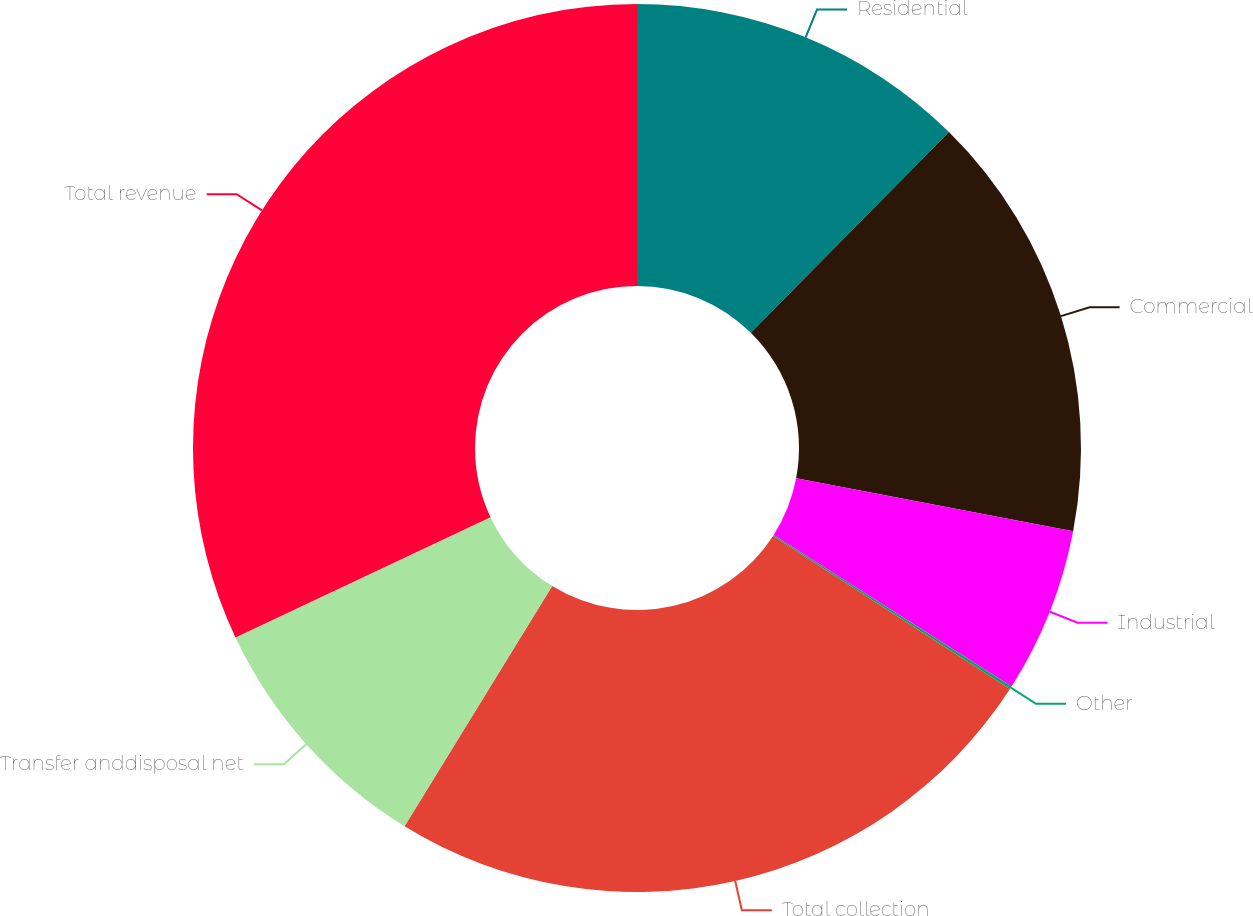Convert chart. <chart><loc_0><loc_0><loc_500><loc_500><pie_chart><fcel>Residential<fcel>Commercial<fcel>Industrial<fcel>Other<fcel>Total collection<fcel>Transfer anddisposal net<fcel>Total revenue<nl><fcel>12.4%<fcel>15.6%<fcel>6.02%<fcel>0.11%<fcel>24.64%<fcel>9.21%<fcel>32.02%<nl></chart> 